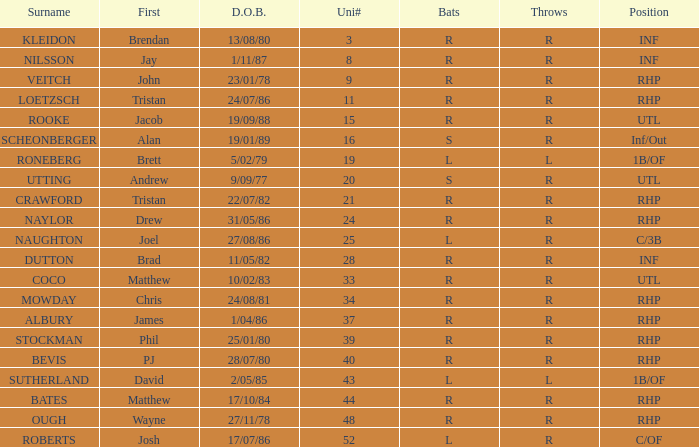Which Uni # has a Surname of ough? 48.0. 